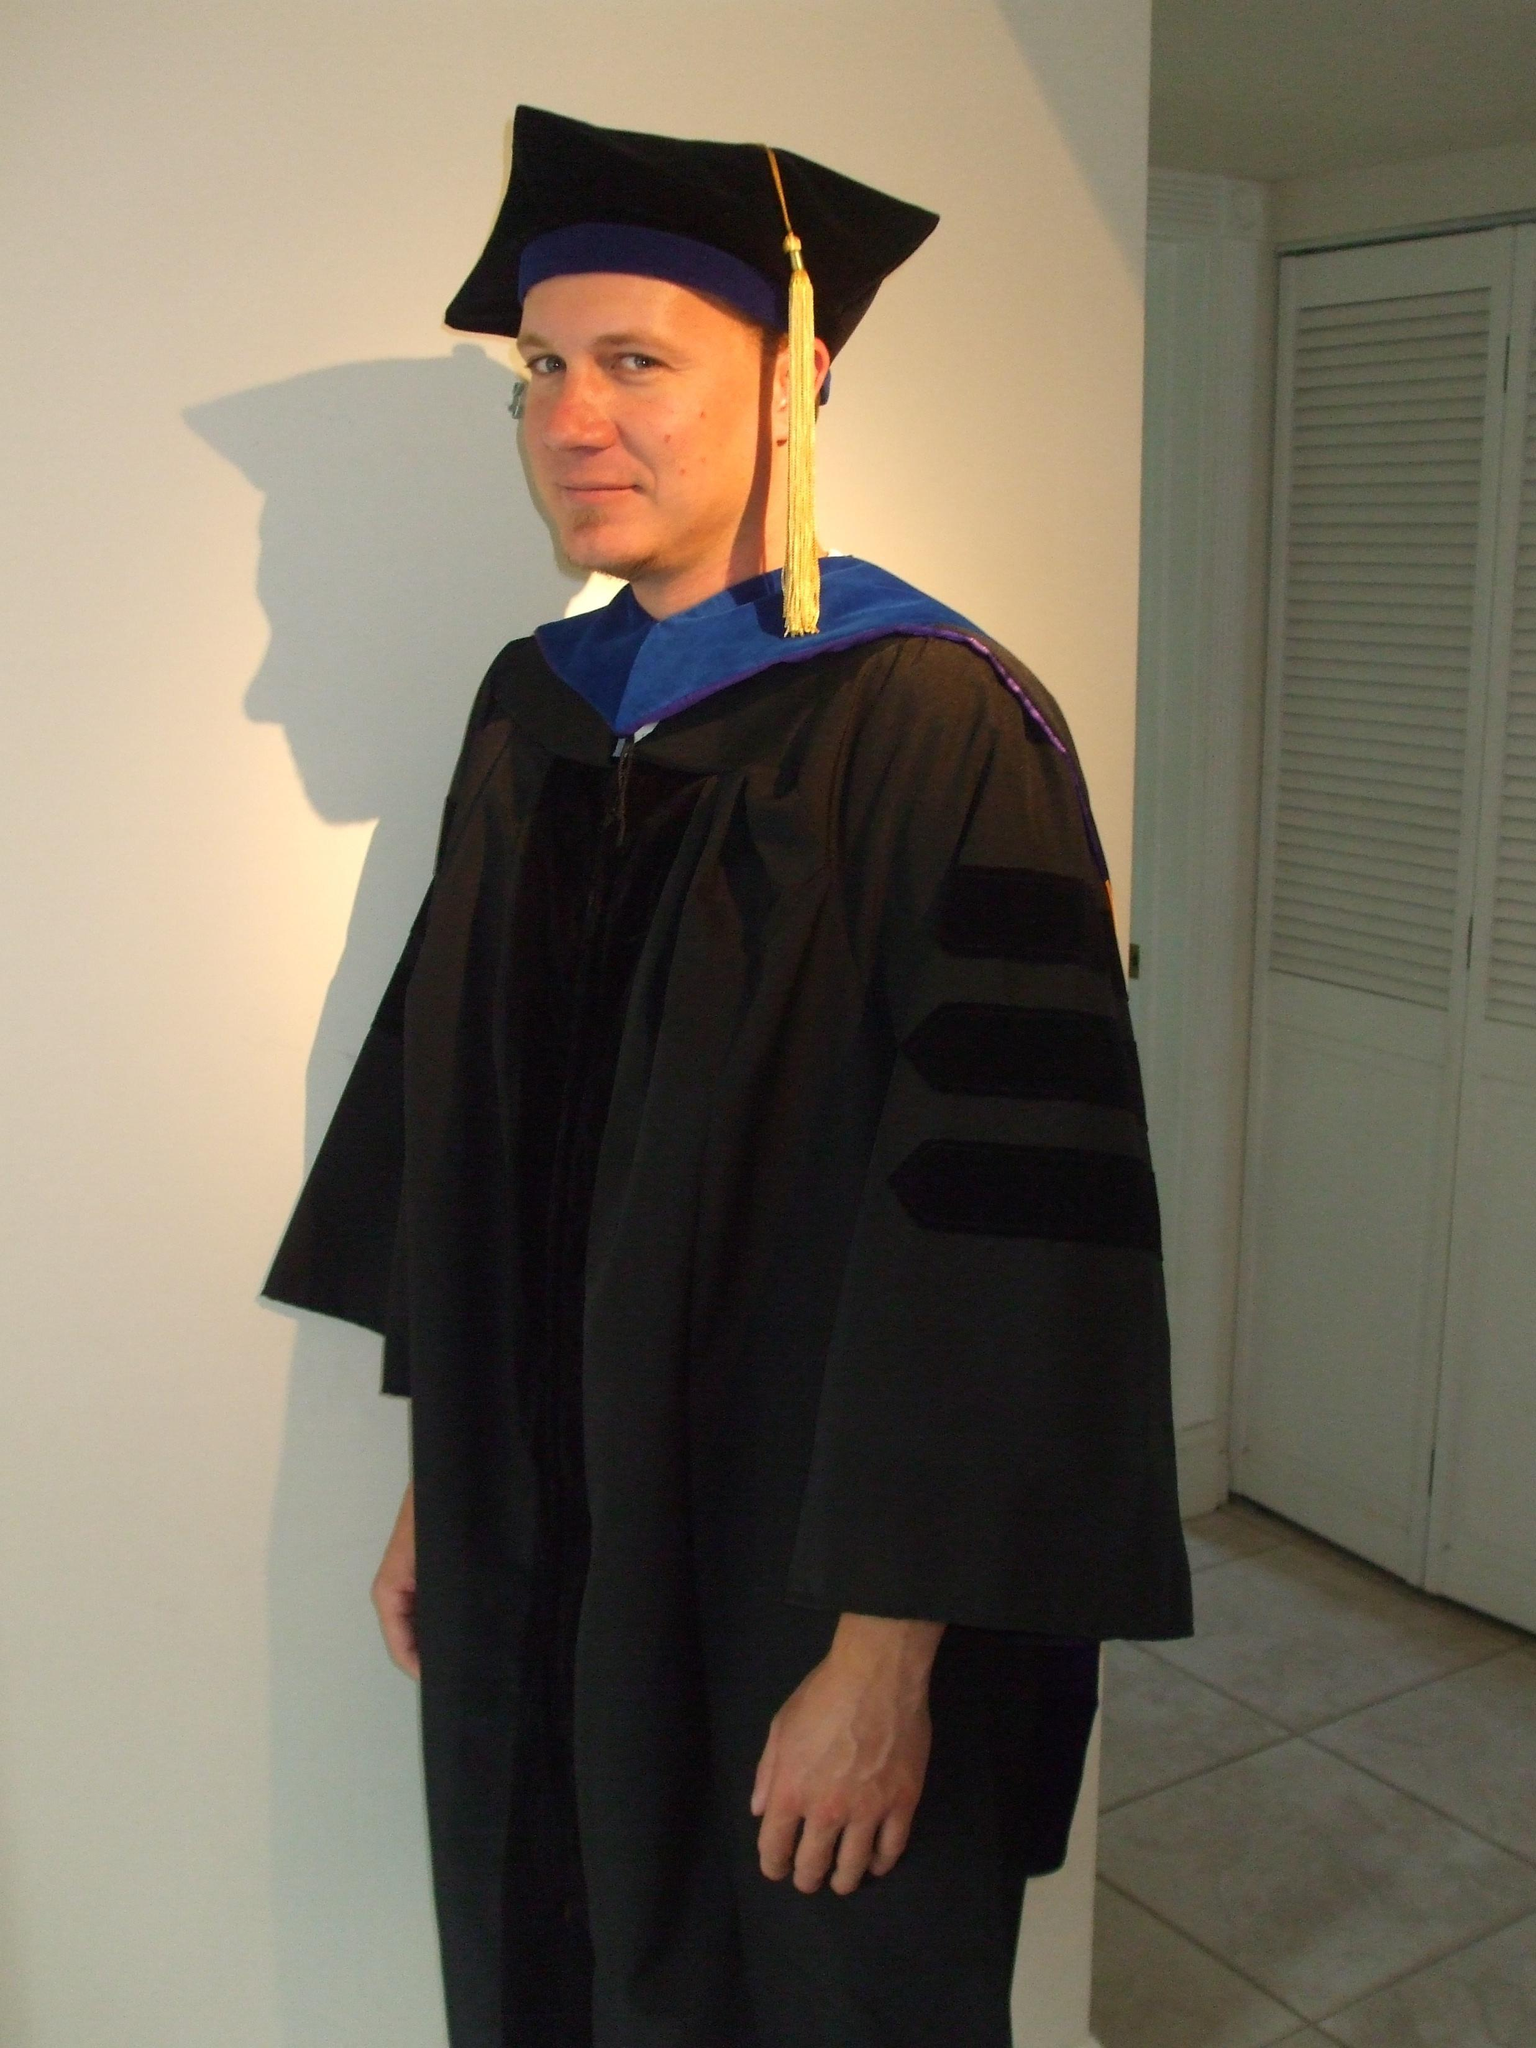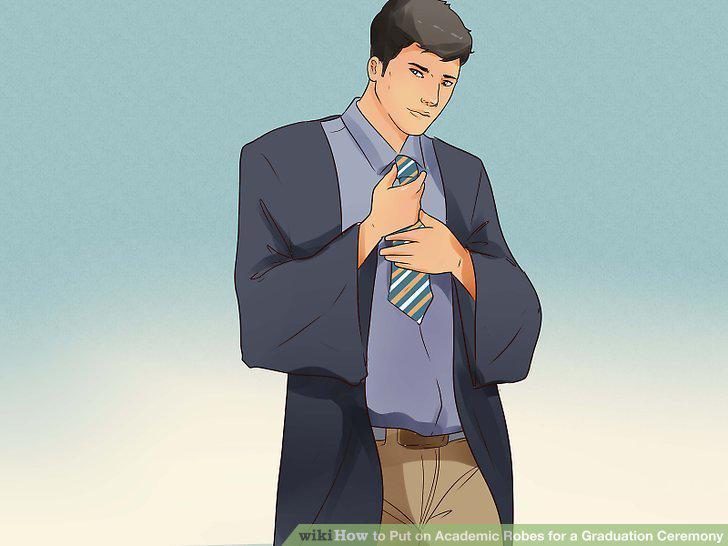The first image is the image on the left, the second image is the image on the right. For the images displayed, is the sentence "The man on the left has a yellow tassel." factually correct? Answer yes or no. Yes. 